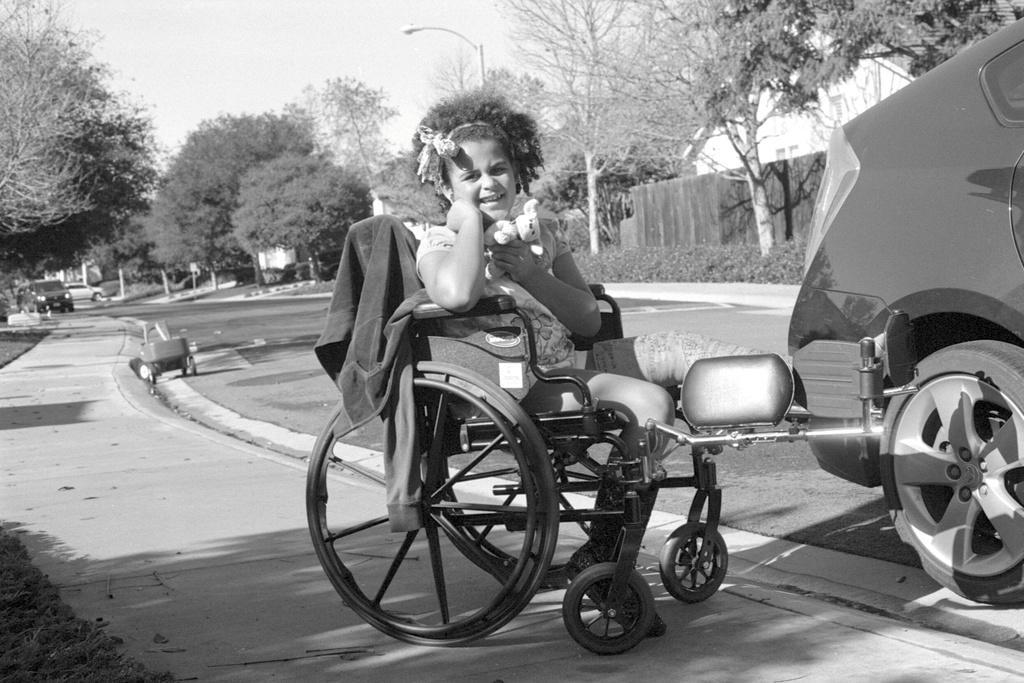Could you give a brief overview of what you see in this image? This is a black and white image and we can see a kid sitting on the wheel chair and there is a coat and we can see a car and a toy trolley. In the background, there are trees, poles, a light and some other vehicles and sheds. At the bottom, there is road and at the top, there is sky. 